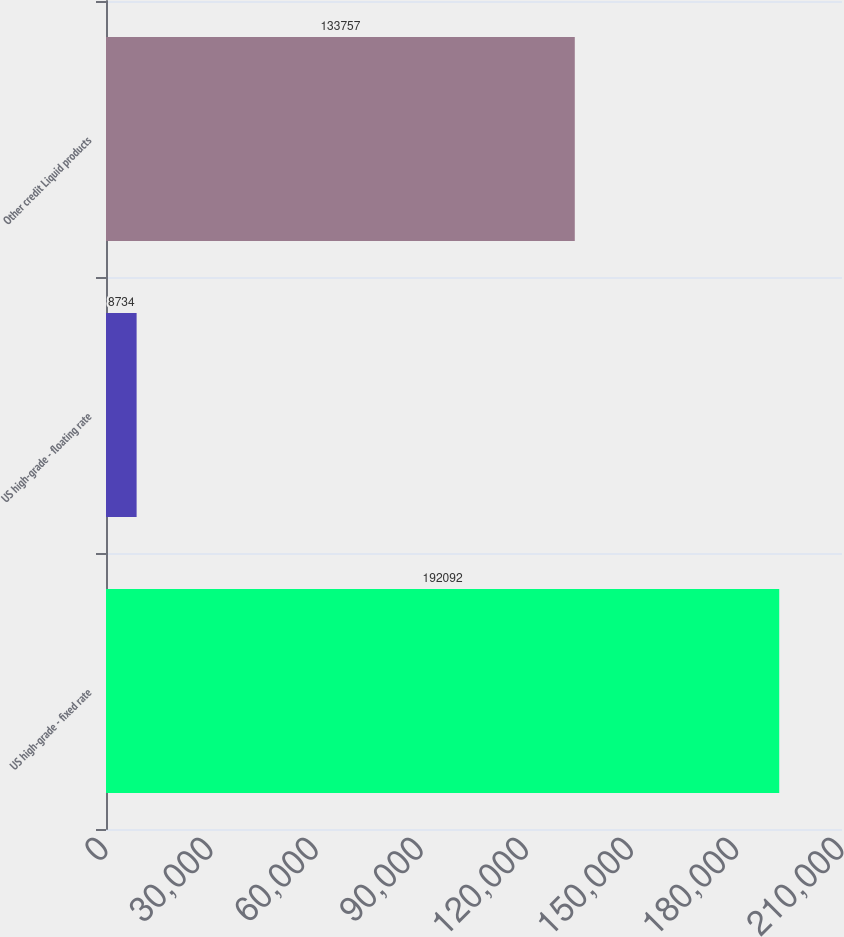Convert chart. <chart><loc_0><loc_0><loc_500><loc_500><bar_chart><fcel>US high-grade - fixed rate<fcel>US high-grade - floating rate<fcel>Other credit Liquid products<nl><fcel>192092<fcel>8734<fcel>133757<nl></chart> 